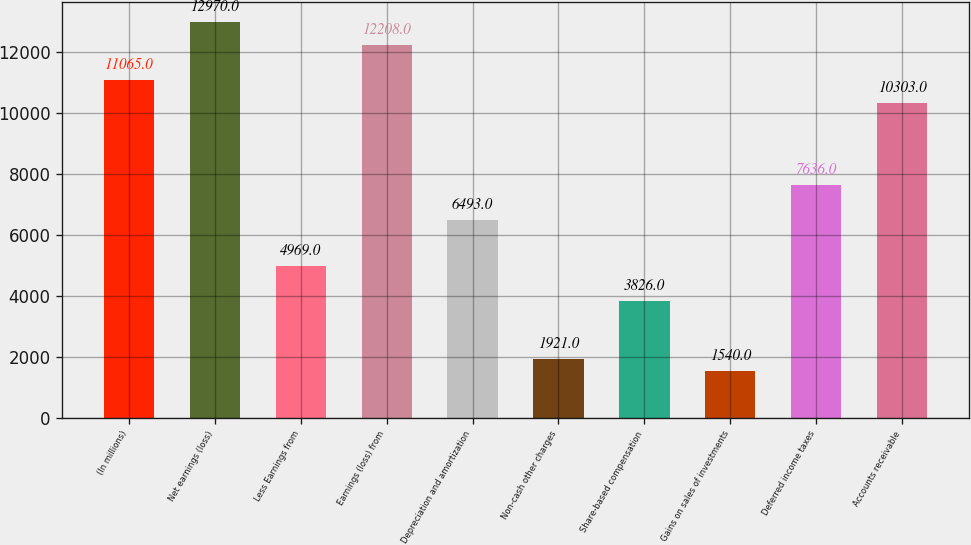Convert chart. <chart><loc_0><loc_0><loc_500><loc_500><bar_chart><fcel>(In millions)<fcel>Net earnings (loss)<fcel>Less Earnings from<fcel>Earnings (loss) from<fcel>Depreciation and amortization<fcel>Non-cash other charges<fcel>Share-based compensation<fcel>Gains on sales of investments<fcel>Deferred income taxes<fcel>Accounts receivable<nl><fcel>11065<fcel>12970<fcel>4969<fcel>12208<fcel>6493<fcel>1921<fcel>3826<fcel>1540<fcel>7636<fcel>10303<nl></chart> 